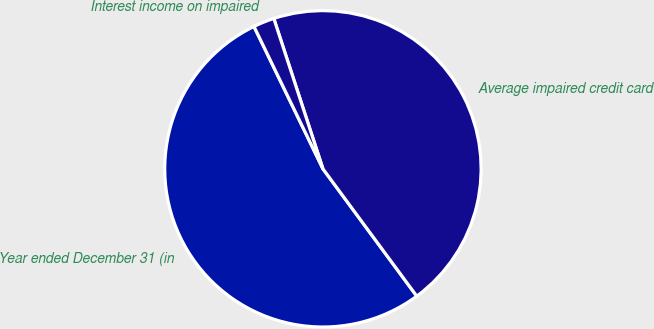<chart> <loc_0><loc_0><loc_500><loc_500><pie_chart><fcel>Year ended December 31 (in<fcel>Average impaired credit card<fcel>Interest income on impaired<nl><fcel>52.93%<fcel>44.92%<fcel>2.15%<nl></chart> 